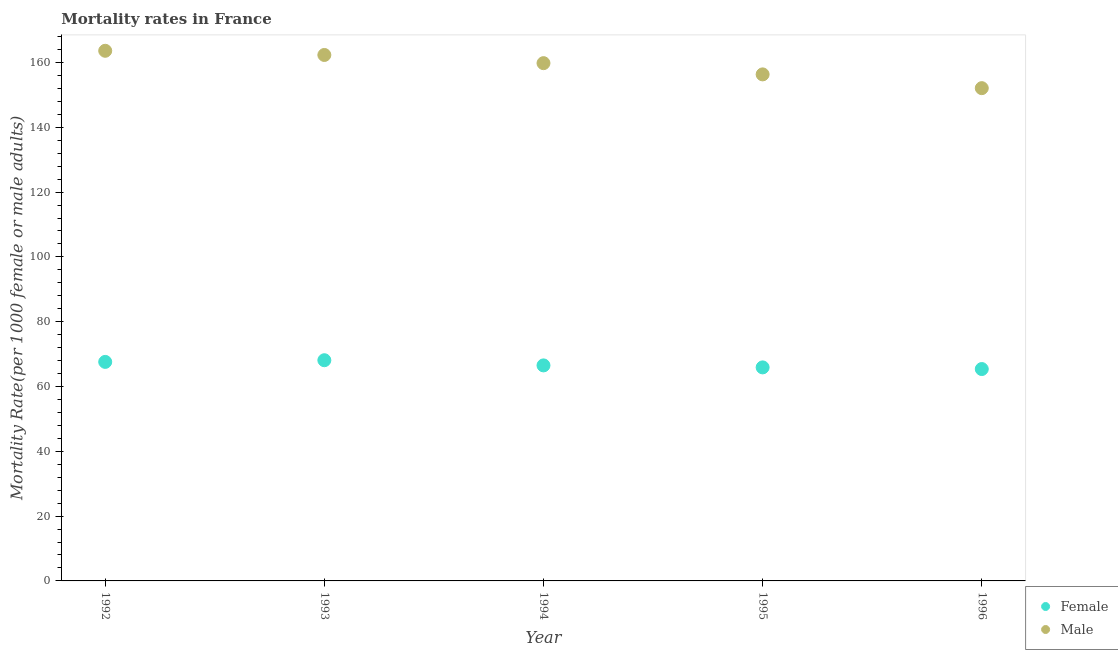What is the female mortality rate in 1995?
Your answer should be compact. 65.9. Across all years, what is the maximum male mortality rate?
Provide a succinct answer. 163.61. Across all years, what is the minimum male mortality rate?
Keep it short and to the point. 152.08. What is the total male mortality rate in the graph?
Your answer should be compact. 794.14. What is the difference between the female mortality rate in 1992 and that in 1994?
Ensure brevity in your answer.  1.08. What is the difference between the male mortality rate in 1994 and the female mortality rate in 1993?
Offer a terse response. 91.68. What is the average male mortality rate per year?
Your answer should be compact. 158.83. In the year 1993, what is the difference between the female mortality rate and male mortality rate?
Your answer should be compact. -94.21. In how many years, is the female mortality rate greater than 12?
Make the answer very short. 5. What is the ratio of the male mortality rate in 1993 to that in 1995?
Your response must be concise. 1.04. Is the male mortality rate in 1992 less than that in 1995?
Make the answer very short. No. Is the difference between the female mortality rate in 1993 and 1994 greater than the difference between the male mortality rate in 1993 and 1994?
Make the answer very short. No. What is the difference between the highest and the second highest female mortality rate?
Your answer should be very brief. 0.52. What is the difference between the highest and the lowest female mortality rate?
Your answer should be compact. 2.72. Is the sum of the male mortality rate in 1992 and 1995 greater than the maximum female mortality rate across all years?
Provide a succinct answer. Yes. Does the male mortality rate monotonically increase over the years?
Offer a terse response. No. Is the female mortality rate strictly less than the male mortality rate over the years?
Provide a short and direct response. Yes. How many dotlines are there?
Make the answer very short. 2. How many years are there in the graph?
Provide a succinct answer. 5. What is the difference between two consecutive major ticks on the Y-axis?
Keep it short and to the point. 20. Does the graph contain any zero values?
Give a very brief answer. No. What is the title of the graph?
Your response must be concise. Mortality rates in France. What is the label or title of the Y-axis?
Keep it short and to the point. Mortality Rate(per 1000 female or male adults). What is the Mortality Rate(per 1000 female or male adults) in Female in 1992?
Provide a short and direct response. 67.6. What is the Mortality Rate(per 1000 female or male adults) of Male in 1992?
Your answer should be very brief. 163.61. What is the Mortality Rate(per 1000 female or male adults) of Female in 1993?
Ensure brevity in your answer.  68.11. What is the Mortality Rate(per 1000 female or male adults) in Male in 1993?
Make the answer very short. 162.32. What is the Mortality Rate(per 1000 female or male adults) of Female in 1994?
Provide a succinct answer. 66.52. What is the Mortality Rate(per 1000 female or male adults) of Male in 1994?
Your answer should be compact. 159.8. What is the Mortality Rate(per 1000 female or male adults) of Female in 1995?
Your answer should be very brief. 65.9. What is the Mortality Rate(per 1000 female or male adults) of Male in 1995?
Your answer should be compact. 156.33. What is the Mortality Rate(per 1000 female or male adults) of Female in 1996?
Make the answer very short. 65.39. What is the Mortality Rate(per 1000 female or male adults) of Male in 1996?
Offer a terse response. 152.08. Across all years, what is the maximum Mortality Rate(per 1000 female or male adults) of Female?
Make the answer very short. 68.11. Across all years, what is the maximum Mortality Rate(per 1000 female or male adults) in Male?
Provide a succinct answer. 163.61. Across all years, what is the minimum Mortality Rate(per 1000 female or male adults) in Female?
Your answer should be very brief. 65.39. Across all years, what is the minimum Mortality Rate(per 1000 female or male adults) of Male?
Ensure brevity in your answer.  152.08. What is the total Mortality Rate(per 1000 female or male adults) of Female in the graph?
Keep it short and to the point. 333.52. What is the total Mortality Rate(per 1000 female or male adults) of Male in the graph?
Provide a succinct answer. 794.14. What is the difference between the Mortality Rate(per 1000 female or male adults) of Female in 1992 and that in 1993?
Offer a terse response. -0.52. What is the difference between the Mortality Rate(per 1000 female or male adults) in Male in 1992 and that in 1993?
Ensure brevity in your answer.  1.29. What is the difference between the Mortality Rate(per 1000 female or male adults) in Female in 1992 and that in 1994?
Your response must be concise. 1.08. What is the difference between the Mortality Rate(per 1000 female or male adults) in Male in 1992 and that in 1994?
Make the answer very short. 3.81. What is the difference between the Mortality Rate(per 1000 female or male adults) in Female in 1992 and that in 1995?
Keep it short and to the point. 1.7. What is the difference between the Mortality Rate(per 1000 female or male adults) of Male in 1992 and that in 1995?
Provide a short and direct response. 7.28. What is the difference between the Mortality Rate(per 1000 female or male adults) in Female in 1992 and that in 1996?
Make the answer very short. 2.21. What is the difference between the Mortality Rate(per 1000 female or male adults) of Male in 1992 and that in 1996?
Your response must be concise. 11.53. What is the difference between the Mortality Rate(per 1000 female or male adults) in Female in 1993 and that in 1994?
Your answer should be compact. 1.6. What is the difference between the Mortality Rate(per 1000 female or male adults) in Male in 1993 and that in 1994?
Provide a short and direct response. 2.52. What is the difference between the Mortality Rate(per 1000 female or male adults) in Female in 1993 and that in 1995?
Your response must be concise. 2.21. What is the difference between the Mortality Rate(per 1000 female or male adults) of Male in 1993 and that in 1995?
Provide a short and direct response. 5.99. What is the difference between the Mortality Rate(per 1000 female or male adults) in Female in 1993 and that in 1996?
Your answer should be compact. 2.72. What is the difference between the Mortality Rate(per 1000 female or male adults) in Male in 1993 and that in 1996?
Provide a succinct answer. 10.24. What is the difference between the Mortality Rate(per 1000 female or male adults) of Female in 1994 and that in 1995?
Give a very brief answer. 0.61. What is the difference between the Mortality Rate(per 1000 female or male adults) of Male in 1994 and that in 1995?
Offer a terse response. 3.47. What is the difference between the Mortality Rate(per 1000 female or male adults) of Female in 1994 and that in 1996?
Offer a very short reply. 1.13. What is the difference between the Mortality Rate(per 1000 female or male adults) of Male in 1994 and that in 1996?
Your answer should be very brief. 7.71. What is the difference between the Mortality Rate(per 1000 female or male adults) in Female in 1995 and that in 1996?
Provide a succinct answer. 0.51. What is the difference between the Mortality Rate(per 1000 female or male adults) in Male in 1995 and that in 1996?
Make the answer very short. 4.25. What is the difference between the Mortality Rate(per 1000 female or male adults) of Female in 1992 and the Mortality Rate(per 1000 female or male adults) of Male in 1993?
Offer a very short reply. -94.72. What is the difference between the Mortality Rate(per 1000 female or male adults) in Female in 1992 and the Mortality Rate(per 1000 female or male adults) in Male in 1994?
Give a very brief answer. -92.2. What is the difference between the Mortality Rate(per 1000 female or male adults) in Female in 1992 and the Mortality Rate(per 1000 female or male adults) in Male in 1995?
Offer a very short reply. -88.73. What is the difference between the Mortality Rate(per 1000 female or male adults) in Female in 1992 and the Mortality Rate(per 1000 female or male adults) in Male in 1996?
Give a very brief answer. -84.49. What is the difference between the Mortality Rate(per 1000 female or male adults) of Female in 1993 and the Mortality Rate(per 1000 female or male adults) of Male in 1994?
Your answer should be compact. -91.68. What is the difference between the Mortality Rate(per 1000 female or male adults) in Female in 1993 and the Mortality Rate(per 1000 female or male adults) in Male in 1995?
Your answer should be very brief. -88.22. What is the difference between the Mortality Rate(per 1000 female or male adults) in Female in 1993 and the Mortality Rate(per 1000 female or male adults) in Male in 1996?
Make the answer very short. -83.97. What is the difference between the Mortality Rate(per 1000 female or male adults) in Female in 1994 and the Mortality Rate(per 1000 female or male adults) in Male in 1995?
Provide a short and direct response. -89.81. What is the difference between the Mortality Rate(per 1000 female or male adults) in Female in 1994 and the Mortality Rate(per 1000 female or male adults) in Male in 1996?
Provide a short and direct response. -85.57. What is the difference between the Mortality Rate(per 1000 female or male adults) of Female in 1995 and the Mortality Rate(per 1000 female or male adults) of Male in 1996?
Make the answer very short. -86.18. What is the average Mortality Rate(per 1000 female or male adults) in Female per year?
Give a very brief answer. 66.7. What is the average Mortality Rate(per 1000 female or male adults) of Male per year?
Your answer should be very brief. 158.83. In the year 1992, what is the difference between the Mortality Rate(per 1000 female or male adults) of Female and Mortality Rate(per 1000 female or male adults) of Male?
Give a very brief answer. -96.02. In the year 1993, what is the difference between the Mortality Rate(per 1000 female or male adults) in Female and Mortality Rate(per 1000 female or male adults) in Male?
Make the answer very short. -94.21. In the year 1994, what is the difference between the Mortality Rate(per 1000 female or male adults) of Female and Mortality Rate(per 1000 female or male adults) of Male?
Offer a terse response. -93.28. In the year 1995, what is the difference between the Mortality Rate(per 1000 female or male adults) in Female and Mortality Rate(per 1000 female or male adults) in Male?
Make the answer very short. -90.43. In the year 1996, what is the difference between the Mortality Rate(per 1000 female or male adults) of Female and Mortality Rate(per 1000 female or male adults) of Male?
Your answer should be very brief. -86.69. What is the ratio of the Mortality Rate(per 1000 female or male adults) in Male in 1992 to that in 1993?
Ensure brevity in your answer.  1.01. What is the ratio of the Mortality Rate(per 1000 female or male adults) of Female in 1992 to that in 1994?
Offer a terse response. 1.02. What is the ratio of the Mortality Rate(per 1000 female or male adults) in Male in 1992 to that in 1994?
Your response must be concise. 1.02. What is the ratio of the Mortality Rate(per 1000 female or male adults) of Female in 1992 to that in 1995?
Make the answer very short. 1.03. What is the ratio of the Mortality Rate(per 1000 female or male adults) in Male in 1992 to that in 1995?
Offer a very short reply. 1.05. What is the ratio of the Mortality Rate(per 1000 female or male adults) in Female in 1992 to that in 1996?
Your answer should be very brief. 1.03. What is the ratio of the Mortality Rate(per 1000 female or male adults) in Male in 1992 to that in 1996?
Provide a succinct answer. 1.08. What is the ratio of the Mortality Rate(per 1000 female or male adults) of Male in 1993 to that in 1994?
Offer a terse response. 1.02. What is the ratio of the Mortality Rate(per 1000 female or male adults) of Female in 1993 to that in 1995?
Your response must be concise. 1.03. What is the ratio of the Mortality Rate(per 1000 female or male adults) of Male in 1993 to that in 1995?
Your answer should be compact. 1.04. What is the ratio of the Mortality Rate(per 1000 female or male adults) in Female in 1993 to that in 1996?
Offer a very short reply. 1.04. What is the ratio of the Mortality Rate(per 1000 female or male adults) in Male in 1993 to that in 1996?
Your response must be concise. 1.07. What is the ratio of the Mortality Rate(per 1000 female or male adults) of Female in 1994 to that in 1995?
Give a very brief answer. 1.01. What is the ratio of the Mortality Rate(per 1000 female or male adults) in Male in 1994 to that in 1995?
Your response must be concise. 1.02. What is the ratio of the Mortality Rate(per 1000 female or male adults) of Female in 1994 to that in 1996?
Provide a succinct answer. 1.02. What is the ratio of the Mortality Rate(per 1000 female or male adults) of Male in 1994 to that in 1996?
Your response must be concise. 1.05. What is the ratio of the Mortality Rate(per 1000 female or male adults) of Male in 1995 to that in 1996?
Make the answer very short. 1.03. What is the difference between the highest and the second highest Mortality Rate(per 1000 female or male adults) of Female?
Offer a terse response. 0.52. What is the difference between the highest and the second highest Mortality Rate(per 1000 female or male adults) in Male?
Your response must be concise. 1.29. What is the difference between the highest and the lowest Mortality Rate(per 1000 female or male adults) in Female?
Keep it short and to the point. 2.72. What is the difference between the highest and the lowest Mortality Rate(per 1000 female or male adults) of Male?
Your answer should be compact. 11.53. 